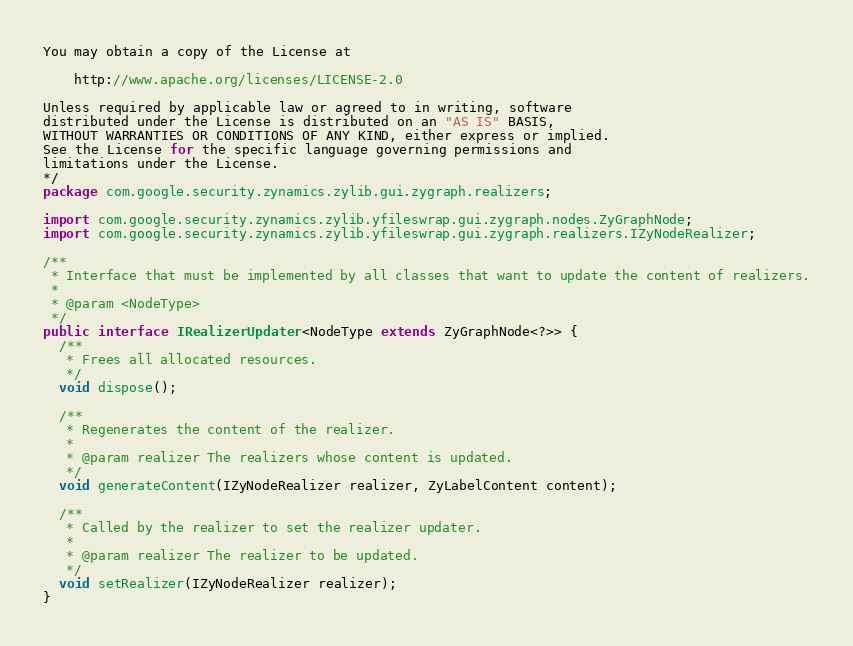<code> <loc_0><loc_0><loc_500><loc_500><_Java_>You may obtain a copy of the License at

    http://www.apache.org/licenses/LICENSE-2.0

Unless required by applicable law or agreed to in writing, software
distributed under the License is distributed on an "AS IS" BASIS,
WITHOUT WARRANTIES OR CONDITIONS OF ANY KIND, either express or implied.
See the License for the specific language governing permissions and
limitations under the License.
*/
package com.google.security.zynamics.zylib.gui.zygraph.realizers;

import com.google.security.zynamics.zylib.yfileswrap.gui.zygraph.nodes.ZyGraphNode;
import com.google.security.zynamics.zylib.yfileswrap.gui.zygraph.realizers.IZyNodeRealizer;

/**
 * Interface that must be implemented by all classes that want to update the content of realizers.
 * 
 * @param <NodeType>
 */
public interface IRealizerUpdater<NodeType extends ZyGraphNode<?>> {
  /**
   * Frees all allocated resources.
   */
  void dispose();

  /**
   * Regenerates the content of the realizer.
   * 
   * @param realizer The realizers whose content is updated.
   */
  void generateContent(IZyNodeRealizer realizer, ZyLabelContent content);

  /**
   * Called by the realizer to set the realizer updater.
   * 
   * @param realizer The realizer to be updated.
   */
  void setRealizer(IZyNodeRealizer realizer);
}
</code> 